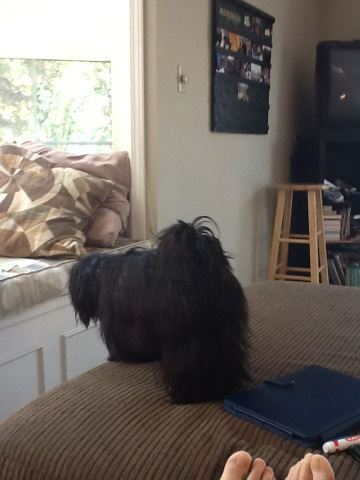Create a story where this dog is the main character in a dramatic situation. In a small, peaceful village nestled in the valley, there was a dog named Shadow. One day, the village fell under the spell of an evil sorcerer, putting all the villagers into a deep sleep. Only Shadow remained awake. Determined to save its beloved humans, Shadow embarked on a perilous journey to find the legendary Crystal of Awakening. Through dark forests, across perilous mountains, and into the heart of the sorcerer's lair, Shadow faced numerous challenges. It encountered fierce guardians of the Crystal and used its wits and bravery to overcome each obstacle. Finally, after a gripping battle with the sorcerer himself, Shadow managed to grab the Crystal and used its magical light to break the spell, waking all the villagers and restoring peace. The once sleepy village hailed Shadow as a hero, and forever after, tales of its courage were passed down through generations. Tell me a short interaction in the life of this dog. In the early morning light, Shadow woke up its owner with gentle nudges, signaling it was time for their morning walk. They walked to the nearby park where Shadow greeted its canine friends with enthusiastic barks and playful jumps. After some fun in the park, they returned home where Shadow received a treat for being such a well-behaved dog. The day continued with Shadow lounging in its favorite sunny spot by the window, watching the world go by contentedly. 